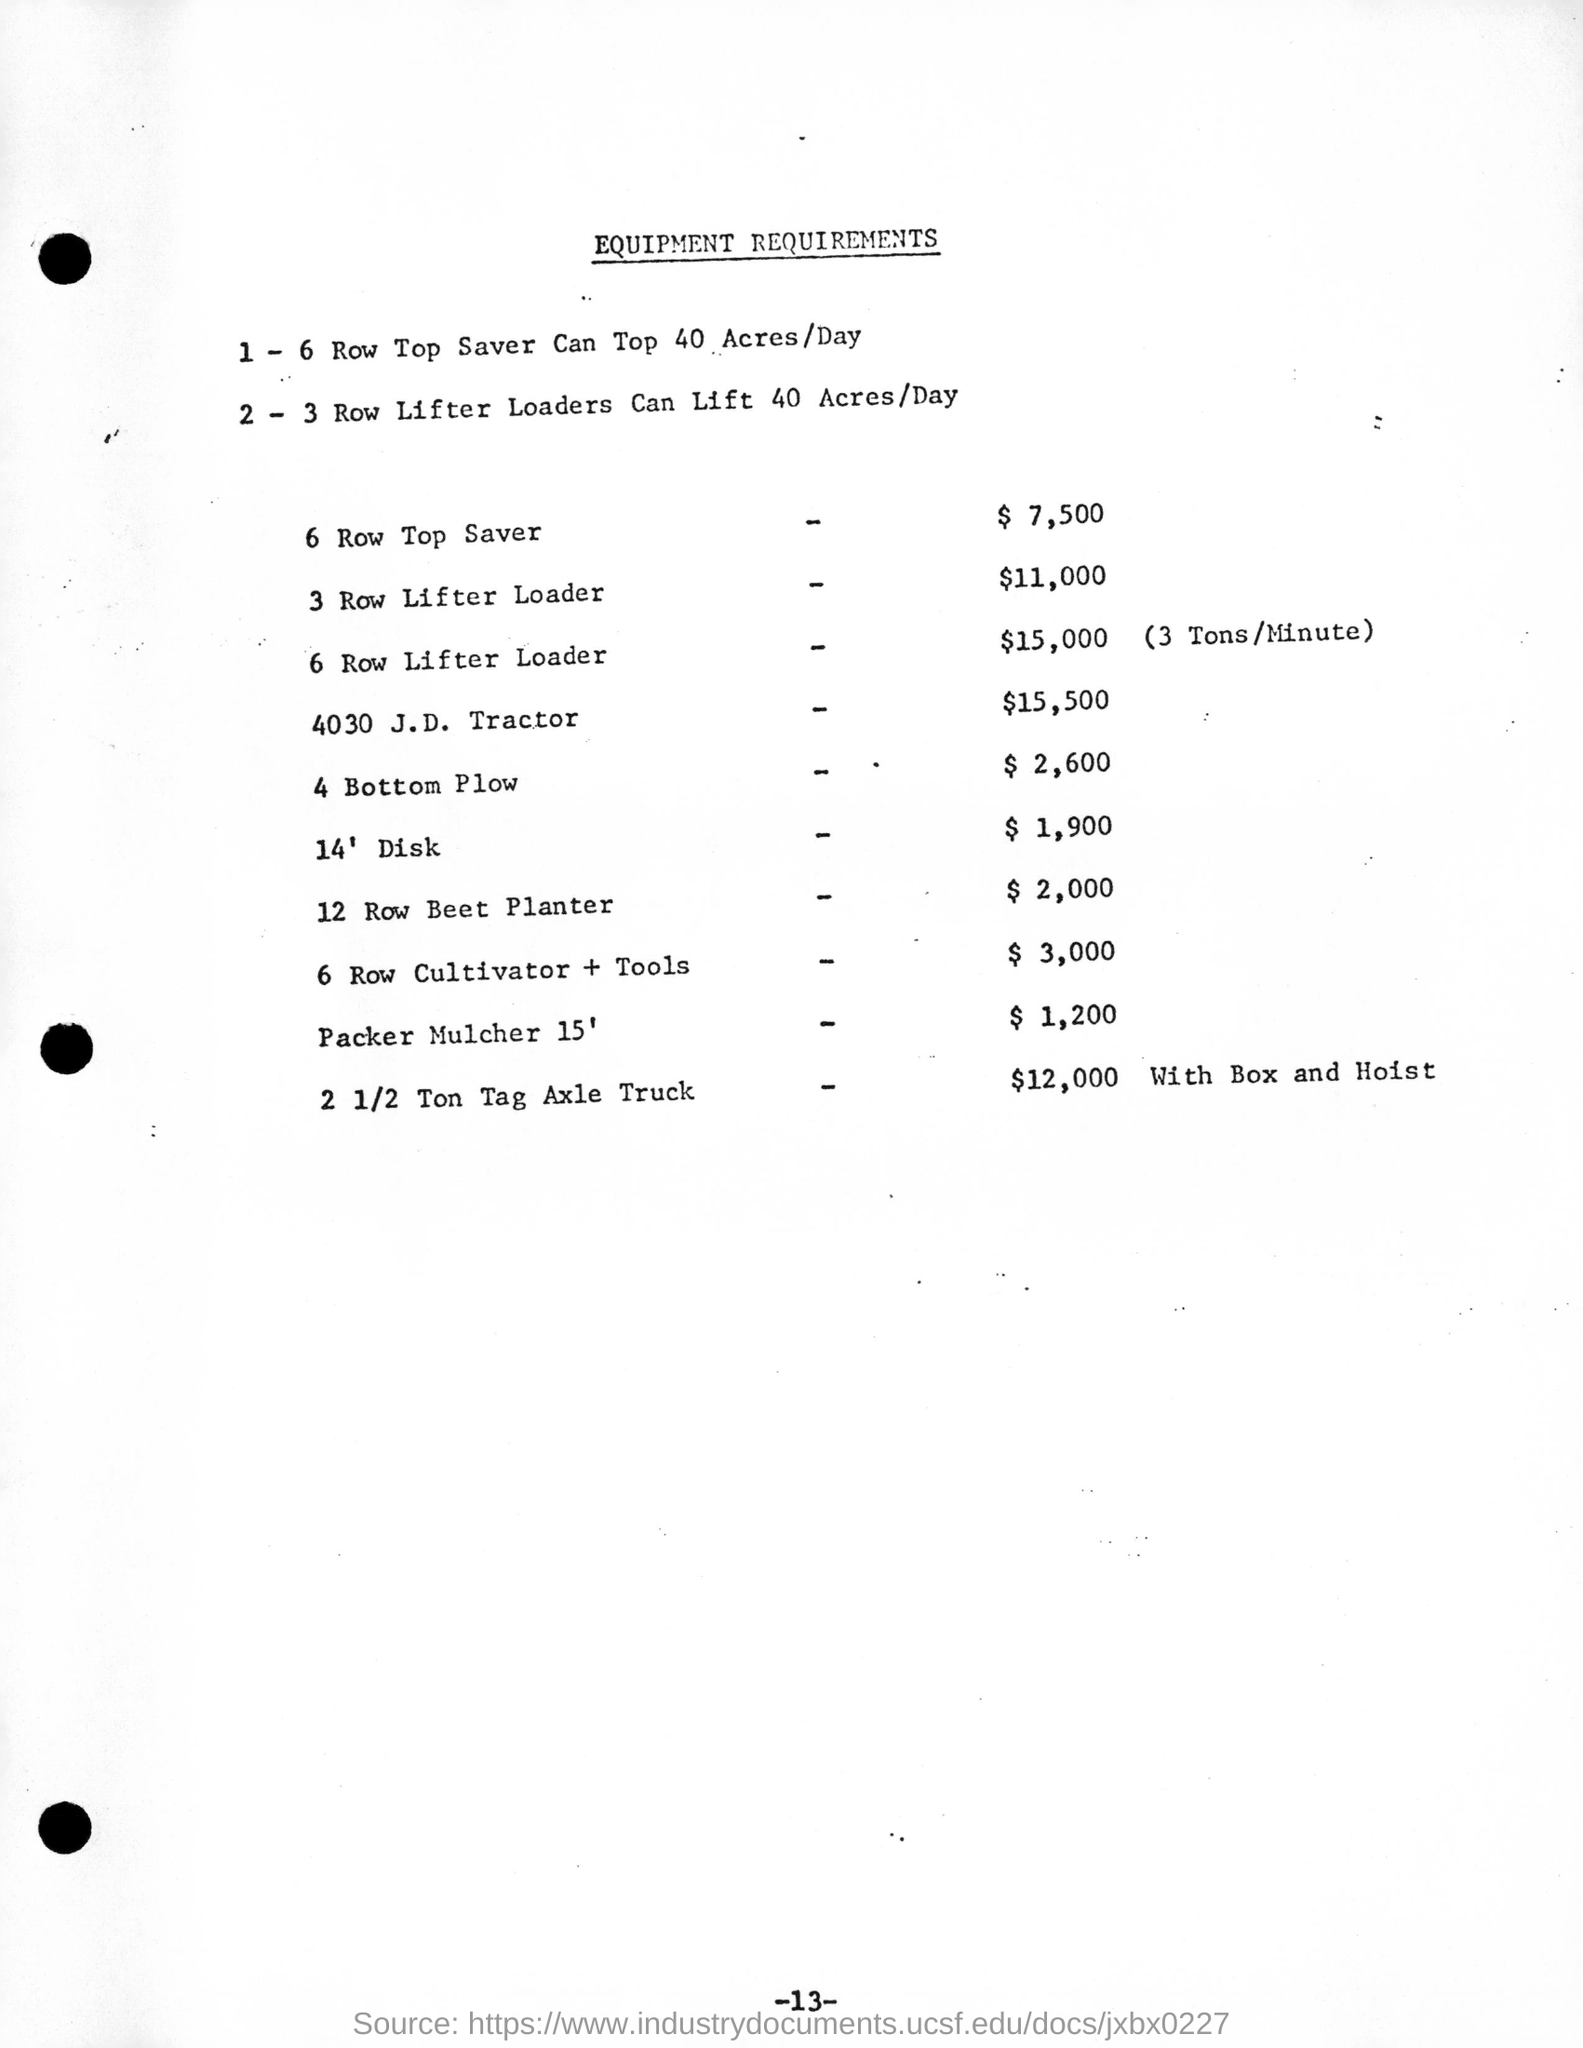Outline some significant characteristics in this image. The 6-row lifter loader can handle up to 3 tons of material per minute. The 2-3 Row Lifter Loaders can lift 40 acres of material per day. The cost of a 12-row beet planter is $2,000. The 6 Row Top Saver is the equipment that costs $7,500. The cost of a 4-bottom plow is $2,600. 